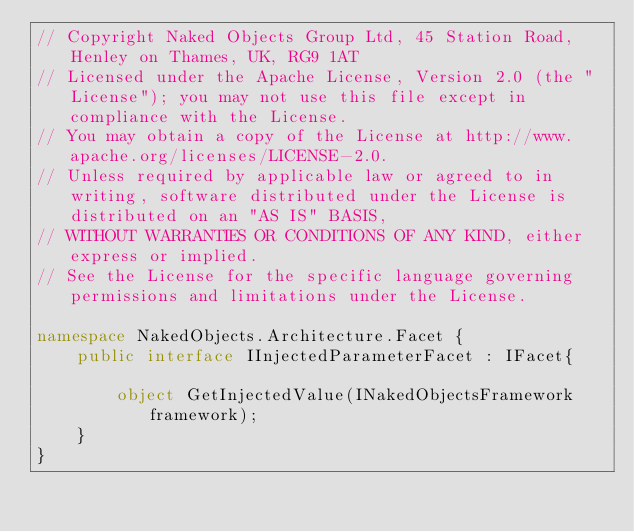Convert code to text. <code><loc_0><loc_0><loc_500><loc_500><_C#_>// Copyright Naked Objects Group Ltd, 45 Station Road, Henley on Thames, UK, RG9 1AT
// Licensed under the Apache License, Version 2.0 (the "License"); you may not use this file except in compliance with the License.
// You may obtain a copy of the License at http://www.apache.org/licenses/LICENSE-2.0.
// Unless required by applicable law or agreed to in writing, software distributed under the License is distributed on an "AS IS" BASIS,
// WITHOUT WARRANTIES OR CONDITIONS OF ANY KIND, either express or implied.
// See the License for the specific language governing permissions and limitations under the License.

namespace NakedObjects.Architecture.Facet {
    public interface IInjectedParameterFacet : IFacet{

        object GetInjectedValue(INakedObjectsFramework framework);
    }
}</code> 